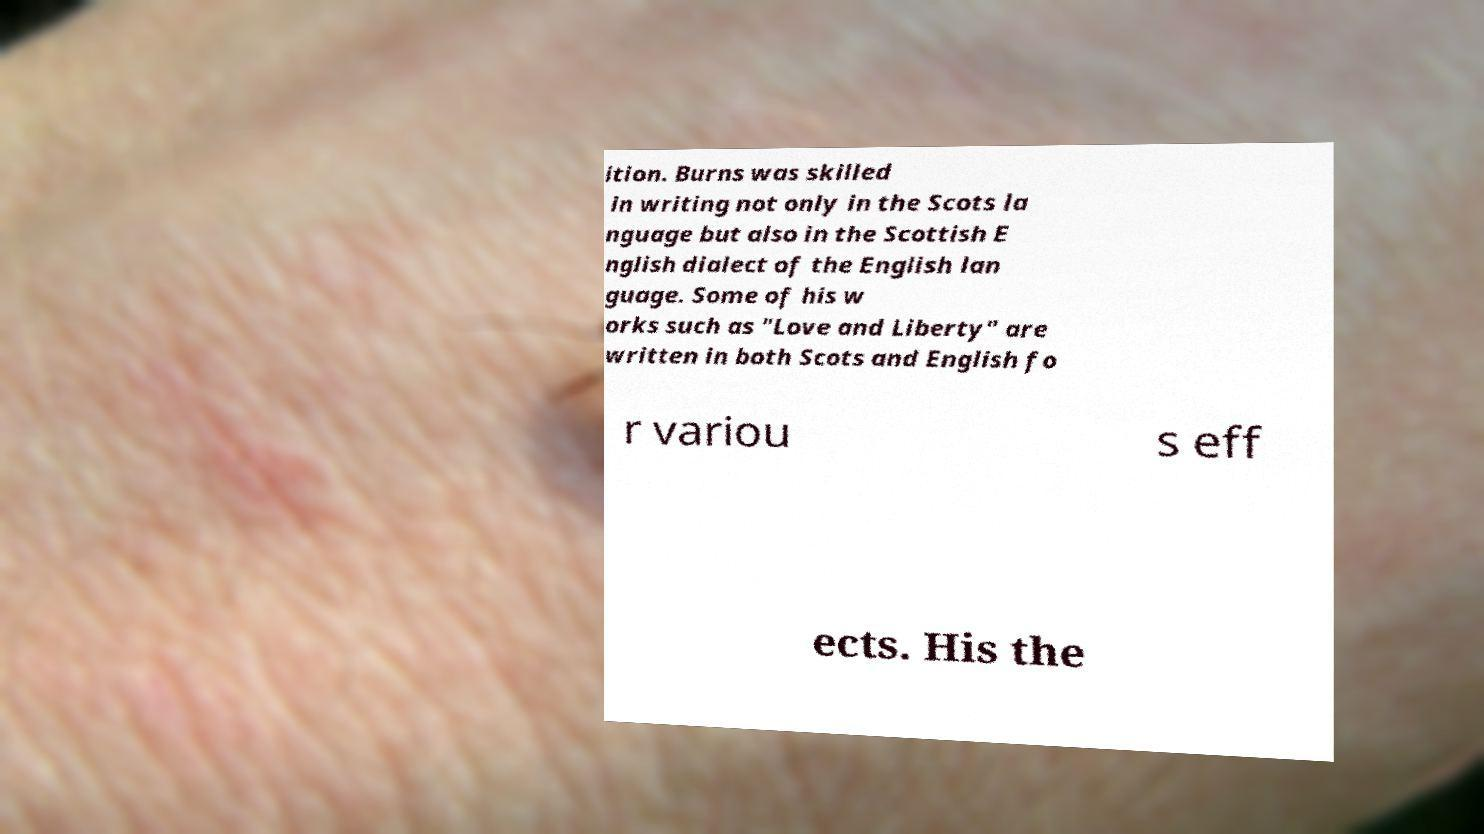Can you read and provide the text displayed in the image?This photo seems to have some interesting text. Can you extract and type it out for me? ition. Burns was skilled in writing not only in the Scots la nguage but also in the Scottish E nglish dialect of the English lan guage. Some of his w orks such as "Love and Liberty" are written in both Scots and English fo r variou s eff ects. His the 